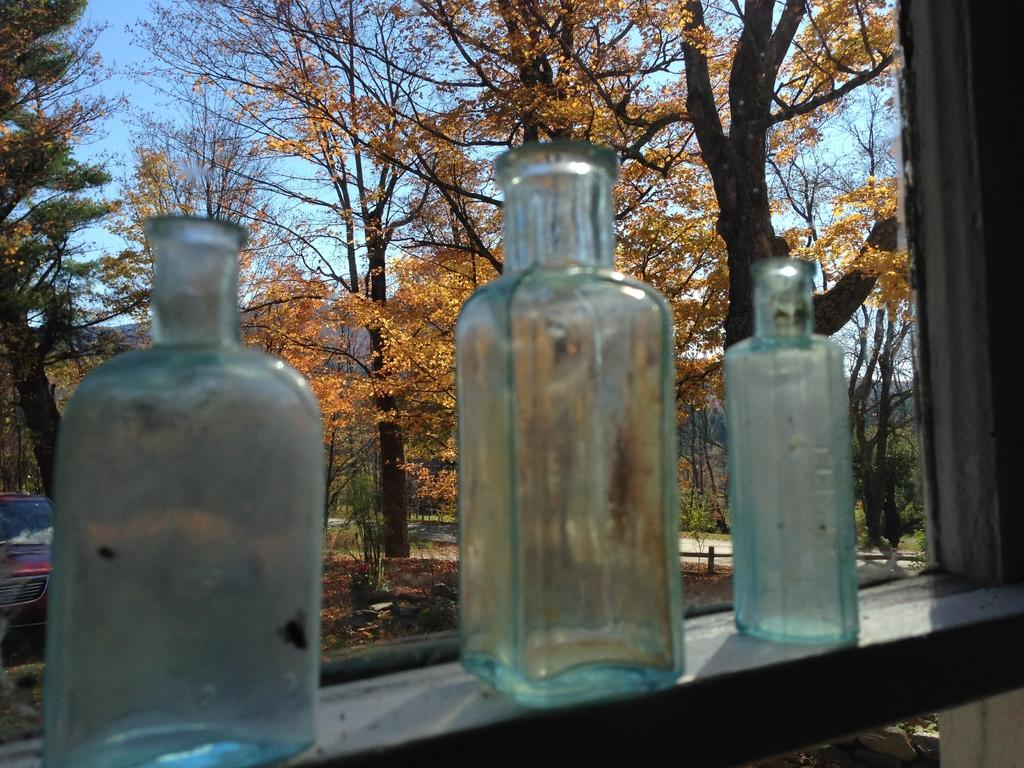What type of vegetation can be seen in the image? There are trees in the image. How many bottles are visible in the image? There are three bottles in the image. Are there any insects crawling on the trees in the image? There is no information about insects in the image, so we cannot determine if any are present. Is there any quicksand visible in the image? There is no quicksand present in the image. Are there any wheels visible in the image? There is no information about wheels in the image, so we cannot determine if any are present. 